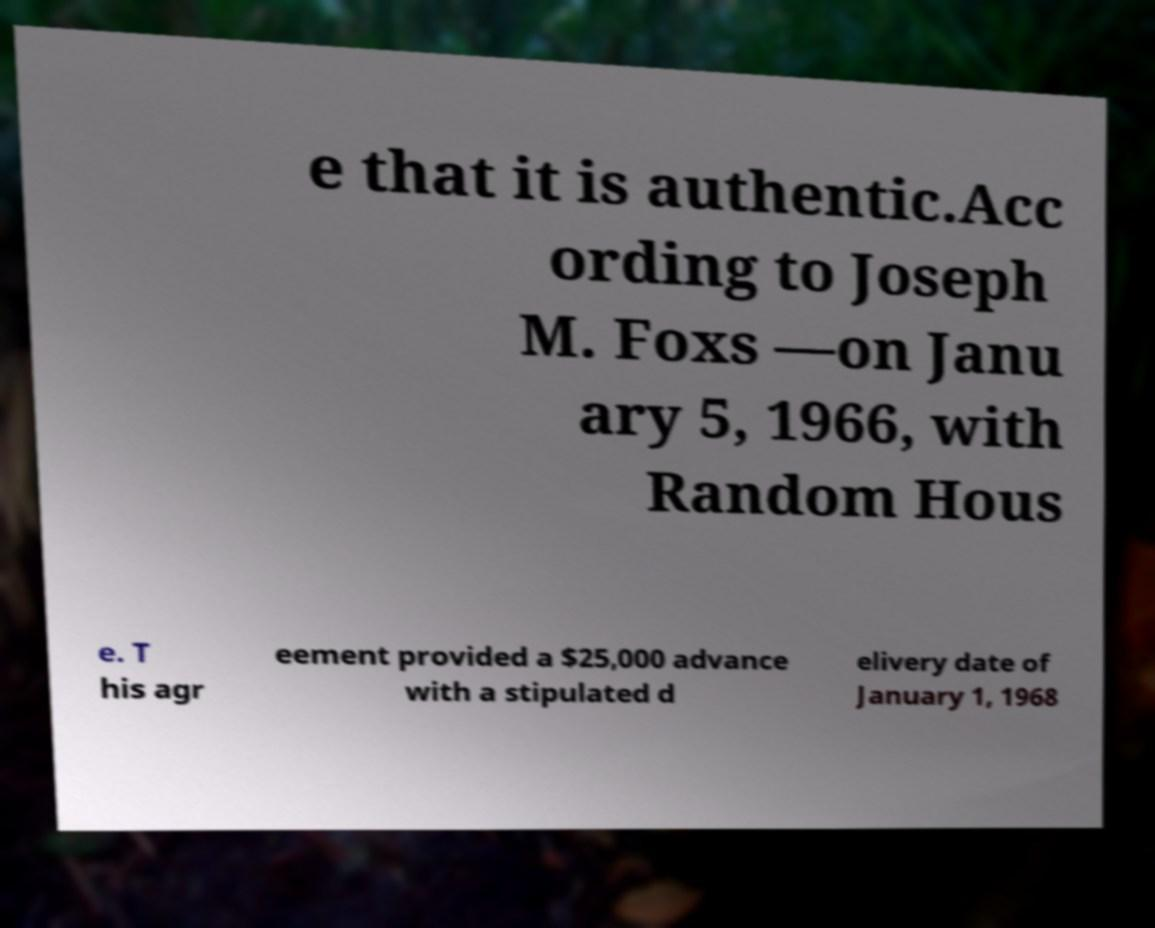Please identify and transcribe the text found in this image. e that it is authentic.Acc ording to Joseph M. Foxs —on Janu ary 5, 1966, with Random Hous e. T his agr eement provided a $25,000 advance with a stipulated d elivery date of January 1, 1968 